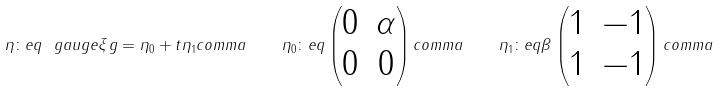<formula> <loc_0><loc_0><loc_500><loc_500>\eta \colon e q \ g a u g e { \xi } { g } = \eta _ { 0 } + t \eta _ { 1 } c o m m a \quad \eta _ { 0 } \colon e q \begin{pmatrix} 0 & \alpha \\ 0 & 0 \end{pmatrix} c o m m a \quad \eta _ { 1 } \colon e q \beta \begin{pmatrix} 1 & - 1 \\ 1 & - 1 \end{pmatrix} c o m m a</formula> 